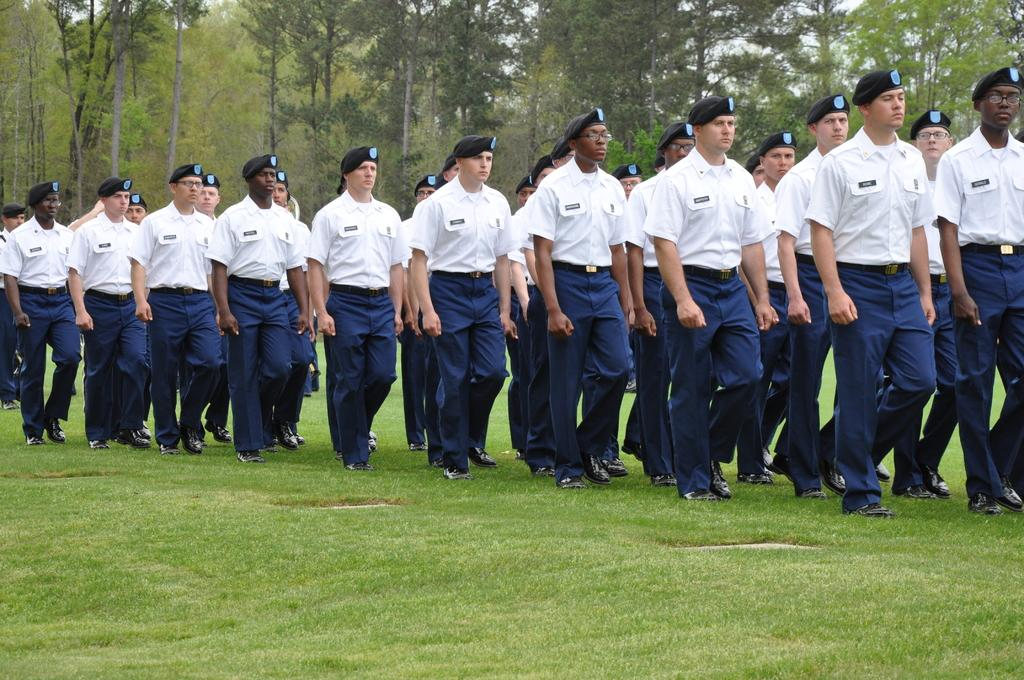What is happening in the image? There is a group of people in the image. What are the people doing? The people are walking on the ground. What can be seen in the background of the image? There are trees in the background of the image. What type of foot is visible on the ground in the image? There is no specific foot mentioned or visible in the image; it shows a group of people walking on the ground. 